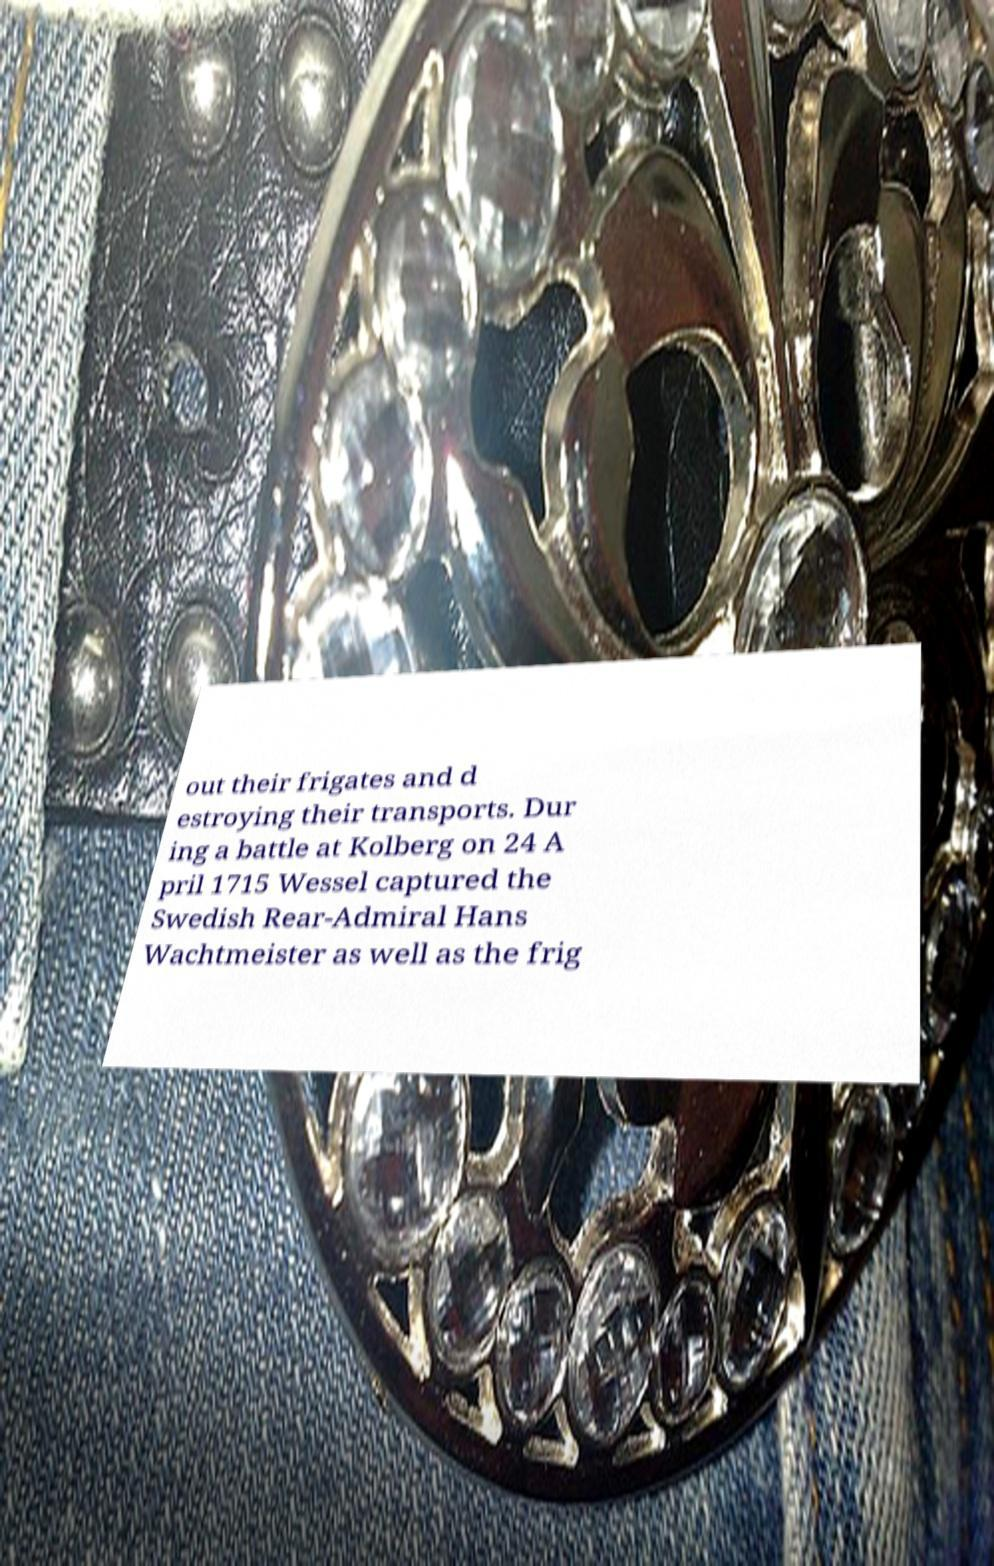There's text embedded in this image that I need extracted. Can you transcribe it verbatim? out their frigates and d estroying their transports. Dur ing a battle at Kolberg on 24 A pril 1715 Wessel captured the Swedish Rear-Admiral Hans Wachtmeister as well as the frig 